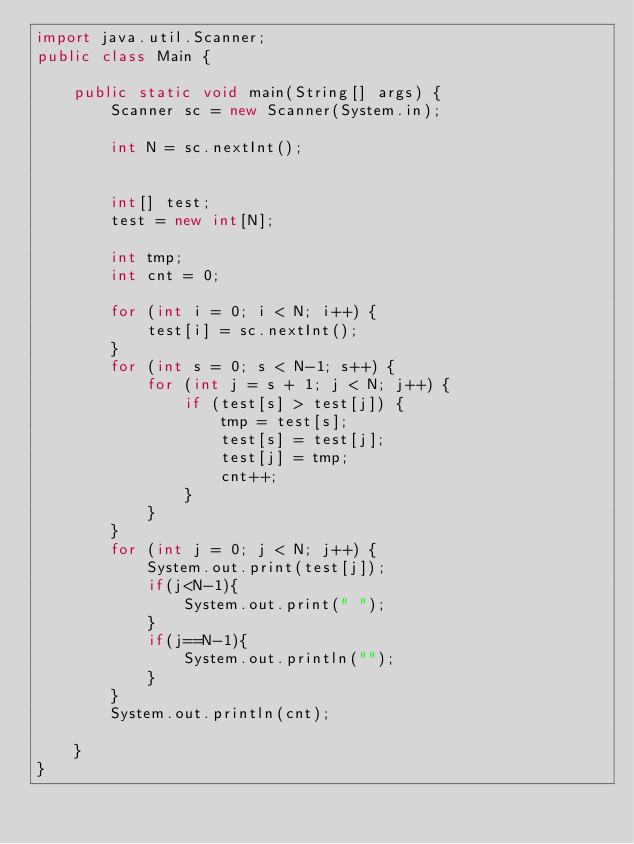<code> <loc_0><loc_0><loc_500><loc_500><_Java_>import java.util.Scanner;
public class Main {

    public static void main(String[] args) {
        Scanner sc = new Scanner(System.in);

        int N = sc.nextInt();


        int[] test;
        test = new int[N];

        int tmp;
        int cnt = 0;

        for (int i = 0; i < N; i++) {
            test[i] = sc.nextInt();
        }
        for (int s = 0; s < N-1; s++) {
            for (int j = s + 1; j < N; j++) {
                if (test[s] > test[j]) {
                    tmp = test[s];
                    test[s] = test[j];
                    test[j] = tmp;
                    cnt++;
                }
            }
        }
        for (int j = 0; j < N; j++) {
            System.out.print(test[j]);
            if(j<N-1){
                System.out.print(" ");
            }
            if(j==N-1){
                System.out.println("");
            }
        }
        System.out.println(cnt);

    }
}

</code> 